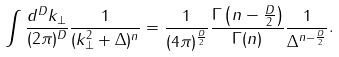Convert formula to latex. <formula><loc_0><loc_0><loc_500><loc_500>\int \frac { d ^ { D } k _ { \perp } } { ( 2 \pi ) ^ { D } } \frac { 1 } { ( k ^ { 2 } _ { \perp } + \Delta ) ^ { n } } = \frac { 1 } { ( 4 \pi ) ^ { \frac { D } { 2 } } } \frac { \Gamma \left ( n - \frac { D } { 2 } \right ) } { \Gamma ( n ) } \frac { 1 } { \Delta ^ { n - \frac { D } { 2 } } } .</formula> 